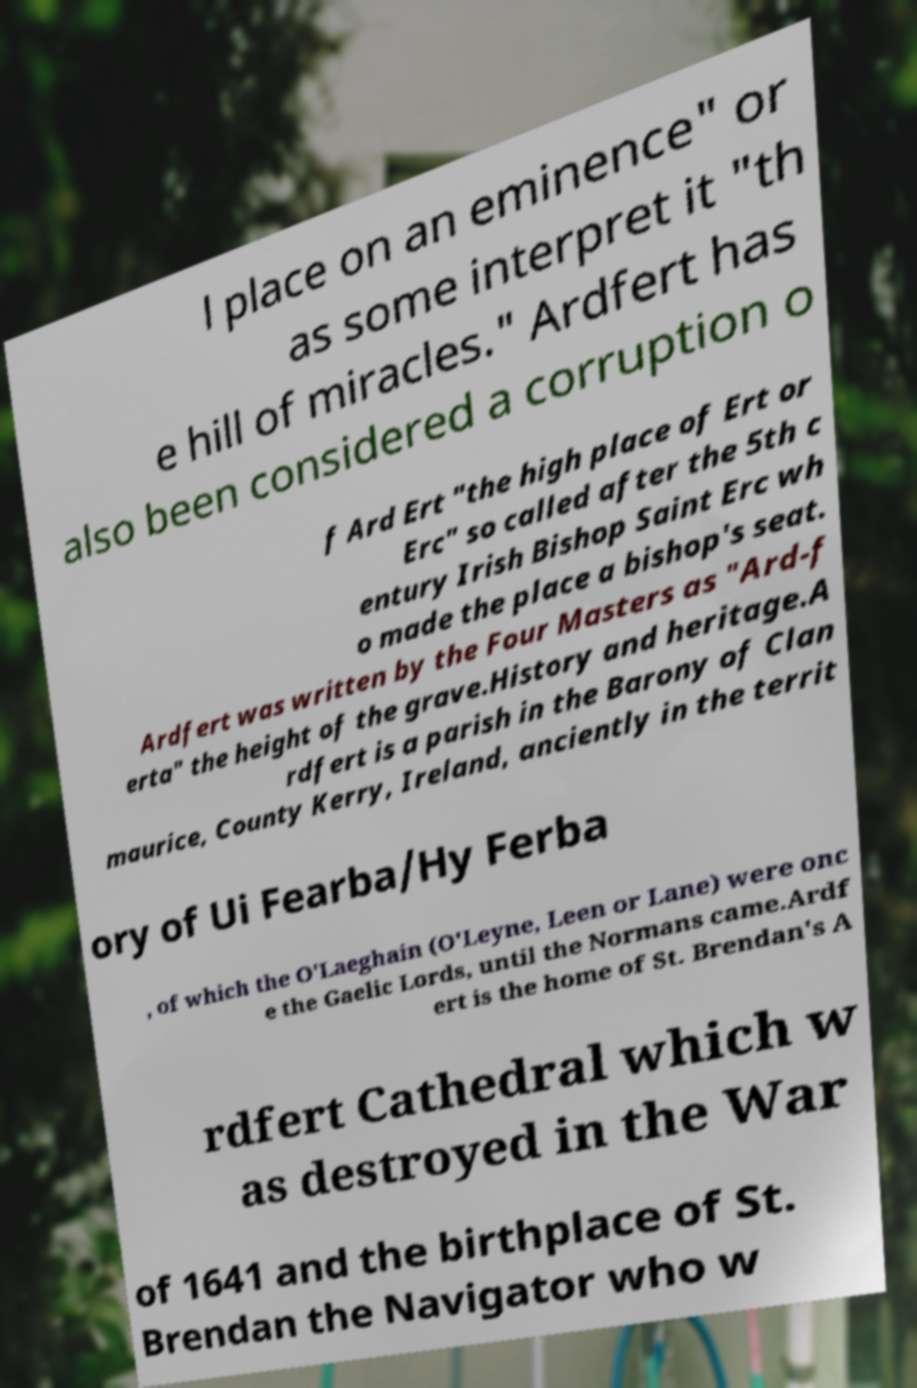Can you read and provide the text displayed in the image?This photo seems to have some interesting text. Can you extract and type it out for me? l place on an eminence" or as some interpret it "th e hill of miracles." Ardfert has also been considered a corruption o f Ard Ert "the high place of Ert or Erc" so called after the 5th c entury Irish Bishop Saint Erc wh o made the place a bishop's seat. Ardfert was written by the Four Masters as "Ard-f erta" the height of the grave.History and heritage.A rdfert is a parish in the Barony of Clan maurice, County Kerry, Ireland, anciently in the territ ory of Ui Fearba/Hy Ferba , of which the O'Laeghain (O'Leyne, Leen or Lane) were onc e the Gaelic Lords, until the Normans came.Ardf ert is the home of St. Brendan's A rdfert Cathedral which w as destroyed in the War of 1641 and the birthplace of St. Brendan the Navigator who w 